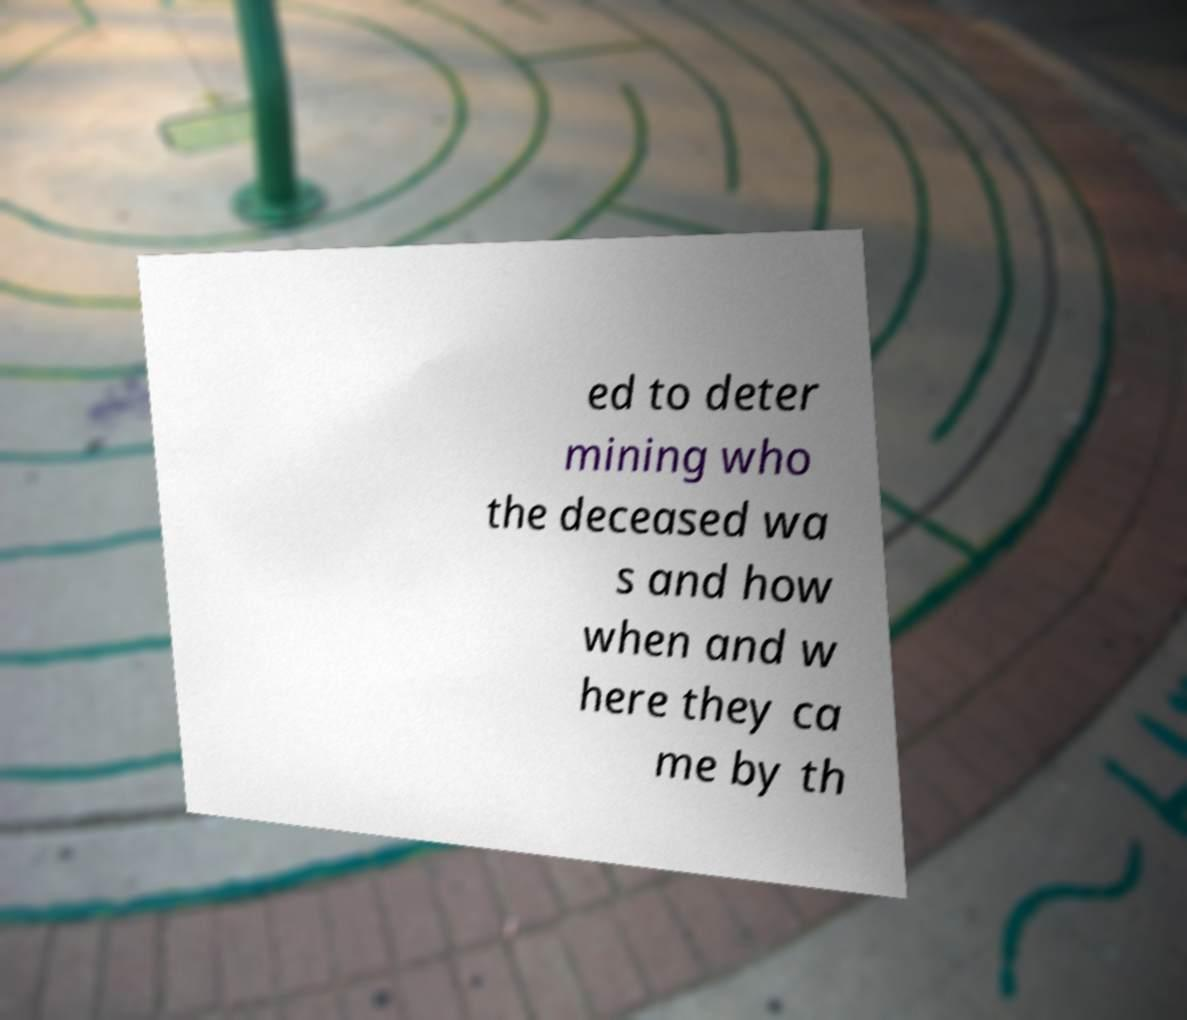There's text embedded in this image that I need extracted. Can you transcribe it verbatim? ed to deter mining who the deceased wa s and how when and w here they ca me by th 